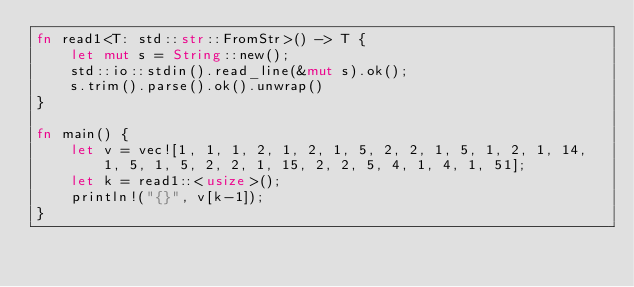<code> <loc_0><loc_0><loc_500><loc_500><_Rust_>fn read1<T: std::str::FromStr>() -> T {
    let mut s = String::new();
    std::io::stdin().read_line(&mut s).ok();
    s.trim().parse().ok().unwrap()
}

fn main() {
    let v = vec![1, 1, 1, 2, 1, 2, 1, 5, 2, 2, 1, 5, 1, 2, 1, 14, 1, 5, 1, 5, 2, 2, 1, 15, 2, 2, 5, 4, 1, 4, 1, 51];
    let k = read1::<usize>();
    println!("{}", v[k-1]);
}</code> 